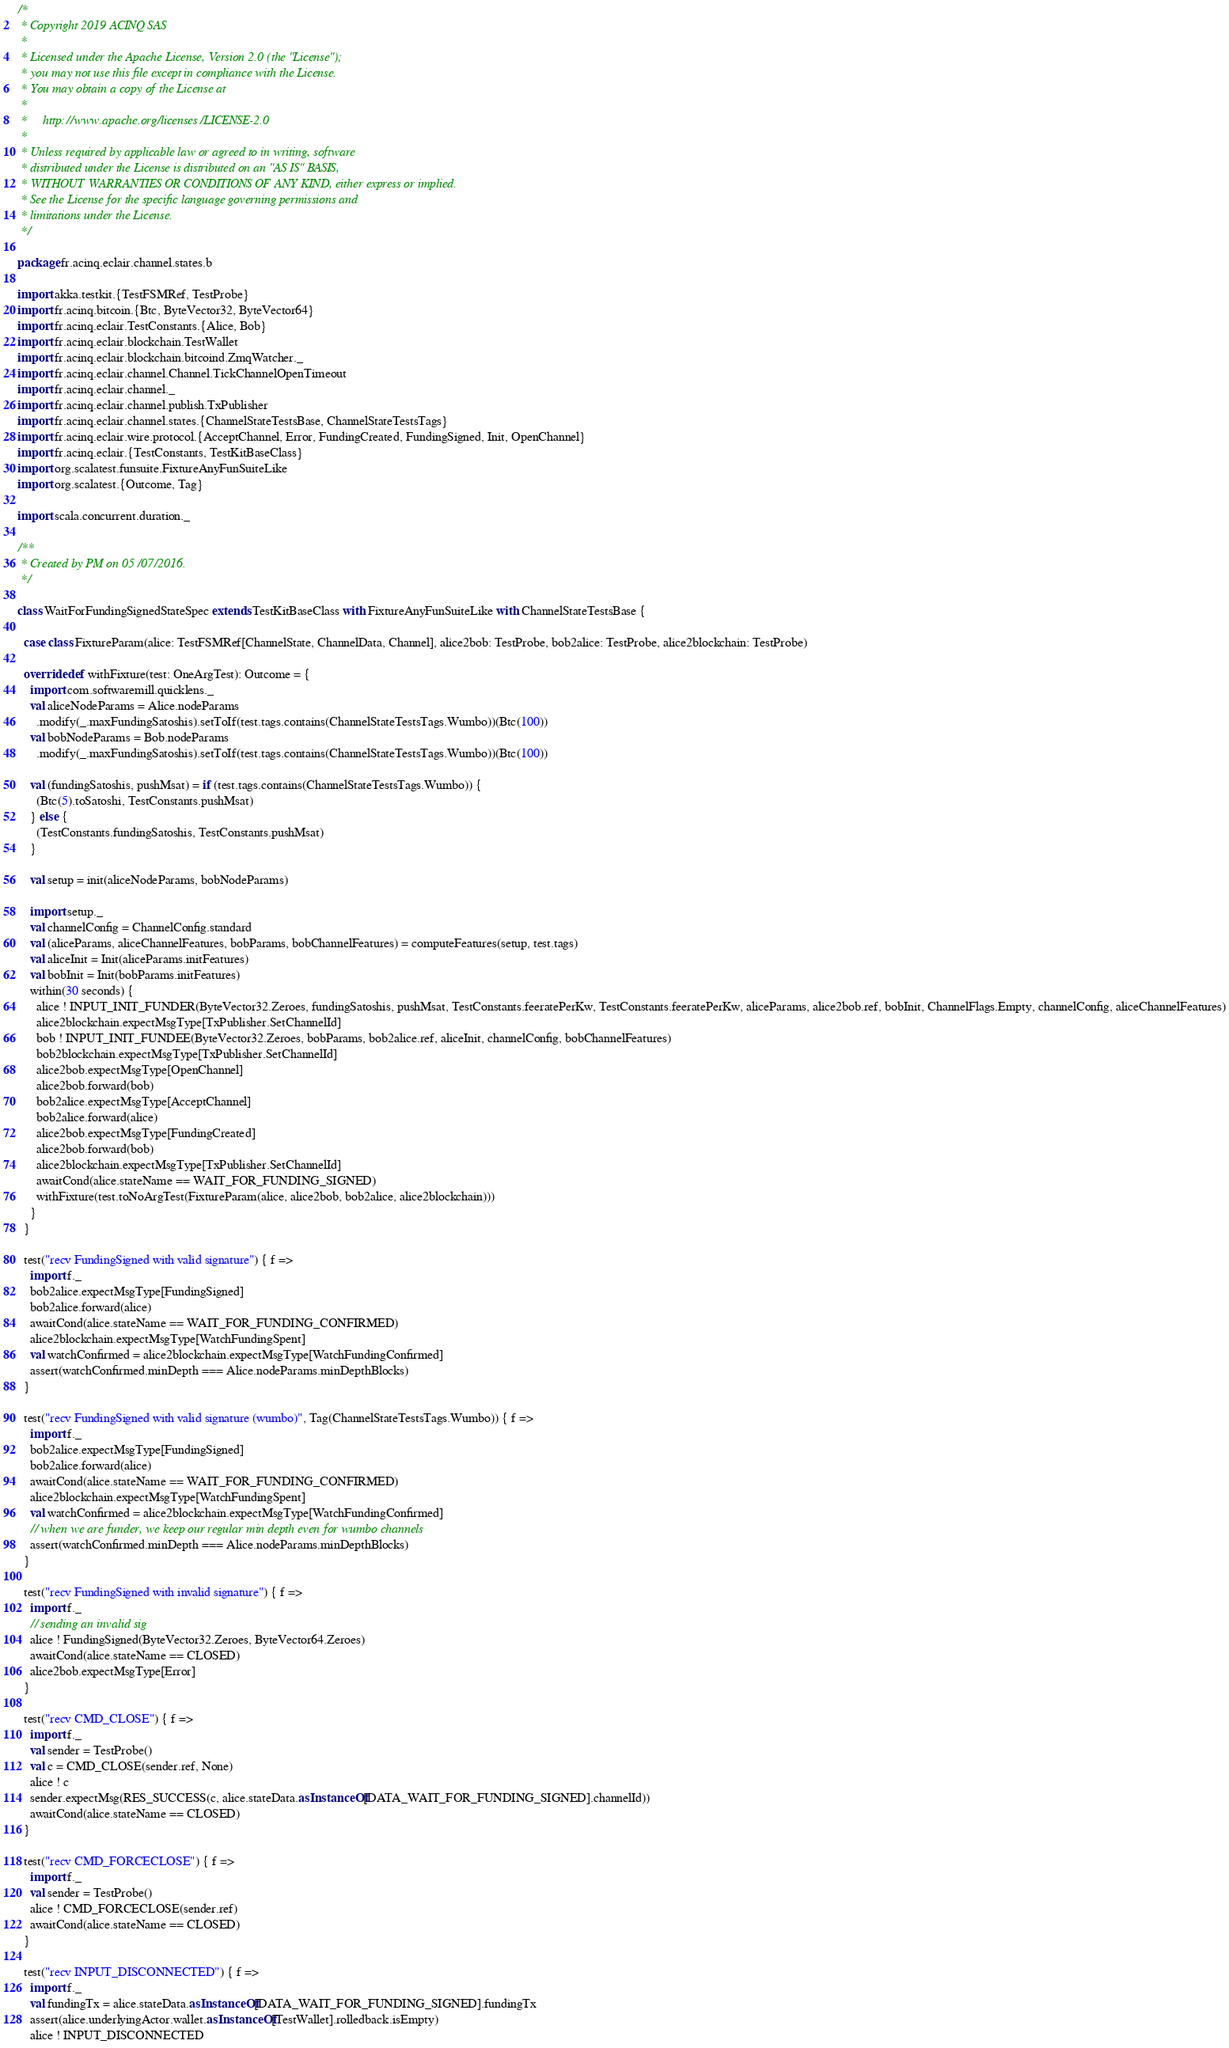<code> <loc_0><loc_0><loc_500><loc_500><_Scala_>/*
 * Copyright 2019 ACINQ SAS
 *
 * Licensed under the Apache License, Version 2.0 (the "License");
 * you may not use this file except in compliance with the License.
 * You may obtain a copy of the License at
 *
 *     http://www.apache.org/licenses/LICENSE-2.0
 *
 * Unless required by applicable law or agreed to in writing, software
 * distributed under the License is distributed on an "AS IS" BASIS,
 * WITHOUT WARRANTIES OR CONDITIONS OF ANY KIND, either express or implied.
 * See the License for the specific language governing permissions and
 * limitations under the License.
 */

package fr.acinq.eclair.channel.states.b

import akka.testkit.{TestFSMRef, TestProbe}
import fr.acinq.bitcoin.{Btc, ByteVector32, ByteVector64}
import fr.acinq.eclair.TestConstants.{Alice, Bob}
import fr.acinq.eclair.blockchain.TestWallet
import fr.acinq.eclair.blockchain.bitcoind.ZmqWatcher._
import fr.acinq.eclair.channel.Channel.TickChannelOpenTimeout
import fr.acinq.eclair.channel._
import fr.acinq.eclair.channel.publish.TxPublisher
import fr.acinq.eclair.channel.states.{ChannelStateTestsBase, ChannelStateTestsTags}
import fr.acinq.eclair.wire.protocol.{AcceptChannel, Error, FundingCreated, FundingSigned, Init, OpenChannel}
import fr.acinq.eclair.{TestConstants, TestKitBaseClass}
import org.scalatest.funsuite.FixtureAnyFunSuiteLike
import org.scalatest.{Outcome, Tag}

import scala.concurrent.duration._

/**
 * Created by PM on 05/07/2016.
 */

class WaitForFundingSignedStateSpec extends TestKitBaseClass with FixtureAnyFunSuiteLike with ChannelStateTestsBase {

  case class FixtureParam(alice: TestFSMRef[ChannelState, ChannelData, Channel], alice2bob: TestProbe, bob2alice: TestProbe, alice2blockchain: TestProbe)

  override def withFixture(test: OneArgTest): Outcome = {
    import com.softwaremill.quicklens._
    val aliceNodeParams = Alice.nodeParams
      .modify(_.maxFundingSatoshis).setToIf(test.tags.contains(ChannelStateTestsTags.Wumbo))(Btc(100))
    val bobNodeParams = Bob.nodeParams
      .modify(_.maxFundingSatoshis).setToIf(test.tags.contains(ChannelStateTestsTags.Wumbo))(Btc(100))

    val (fundingSatoshis, pushMsat) = if (test.tags.contains(ChannelStateTestsTags.Wumbo)) {
      (Btc(5).toSatoshi, TestConstants.pushMsat)
    } else {
      (TestConstants.fundingSatoshis, TestConstants.pushMsat)
    }

    val setup = init(aliceNodeParams, bobNodeParams)

    import setup._
    val channelConfig = ChannelConfig.standard
    val (aliceParams, aliceChannelFeatures, bobParams, bobChannelFeatures) = computeFeatures(setup, test.tags)
    val aliceInit = Init(aliceParams.initFeatures)
    val bobInit = Init(bobParams.initFeatures)
    within(30 seconds) {
      alice ! INPUT_INIT_FUNDER(ByteVector32.Zeroes, fundingSatoshis, pushMsat, TestConstants.feeratePerKw, TestConstants.feeratePerKw, aliceParams, alice2bob.ref, bobInit, ChannelFlags.Empty, channelConfig, aliceChannelFeatures)
      alice2blockchain.expectMsgType[TxPublisher.SetChannelId]
      bob ! INPUT_INIT_FUNDEE(ByteVector32.Zeroes, bobParams, bob2alice.ref, aliceInit, channelConfig, bobChannelFeatures)
      bob2blockchain.expectMsgType[TxPublisher.SetChannelId]
      alice2bob.expectMsgType[OpenChannel]
      alice2bob.forward(bob)
      bob2alice.expectMsgType[AcceptChannel]
      bob2alice.forward(alice)
      alice2bob.expectMsgType[FundingCreated]
      alice2bob.forward(bob)
      alice2blockchain.expectMsgType[TxPublisher.SetChannelId]
      awaitCond(alice.stateName == WAIT_FOR_FUNDING_SIGNED)
      withFixture(test.toNoArgTest(FixtureParam(alice, alice2bob, bob2alice, alice2blockchain)))
    }
  }

  test("recv FundingSigned with valid signature") { f =>
    import f._
    bob2alice.expectMsgType[FundingSigned]
    bob2alice.forward(alice)
    awaitCond(alice.stateName == WAIT_FOR_FUNDING_CONFIRMED)
    alice2blockchain.expectMsgType[WatchFundingSpent]
    val watchConfirmed = alice2blockchain.expectMsgType[WatchFundingConfirmed]
    assert(watchConfirmed.minDepth === Alice.nodeParams.minDepthBlocks)
  }

  test("recv FundingSigned with valid signature (wumbo)", Tag(ChannelStateTestsTags.Wumbo)) { f =>
    import f._
    bob2alice.expectMsgType[FundingSigned]
    bob2alice.forward(alice)
    awaitCond(alice.stateName == WAIT_FOR_FUNDING_CONFIRMED)
    alice2blockchain.expectMsgType[WatchFundingSpent]
    val watchConfirmed = alice2blockchain.expectMsgType[WatchFundingConfirmed]
    // when we are funder, we keep our regular min depth even for wumbo channels
    assert(watchConfirmed.minDepth === Alice.nodeParams.minDepthBlocks)
  }

  test("recv FundingSigned with invalid signature") { f =>
    import f._
    // sending an invalid sig
    alice ! FundingSigned(ByteVector32.Zeroes, ByteVector64.Zeroes)
    awaitCond(alice.stateName == CLOSED)
    alice2bob.expectMsgType[Error]
  }

  test("recv CMD_CLOSE") { f =>
    import f._
    val sender = TestProbe()
    val c = CMD_CLOSE(sender.ref, None)
    alice ! c
    sender.expectMsg(RES_SUCCESS(c, alice.stateData.asInstanceOf[DATA_WAIT_FOR_FUNDING_SIGNED].channelId))
    awaitCond(alice.stateName == CLOSED)
  }

  test("recv CMD_FORCECLOSE") { f =>
    import f._
    val sender = TestProbe()
    alice ! CMD_FORCECLOSE(sender.ref)
    awaitCond(alice.stateName == CLOSED)
  }

  test("recv INPUT_DISCONNECTED") { f =>
    import f._
    val fundingTx = alice.stateData.asInstanceOf[DATA_WAIT_FOR_FUNDING_SIGNED].fundingTx
    assert(alice.underlyingActor.wallet.asInstanceOf[TestWallet].rolledback.isEmpty)
    alice ! INPUT_DISCONNECTED</code> 